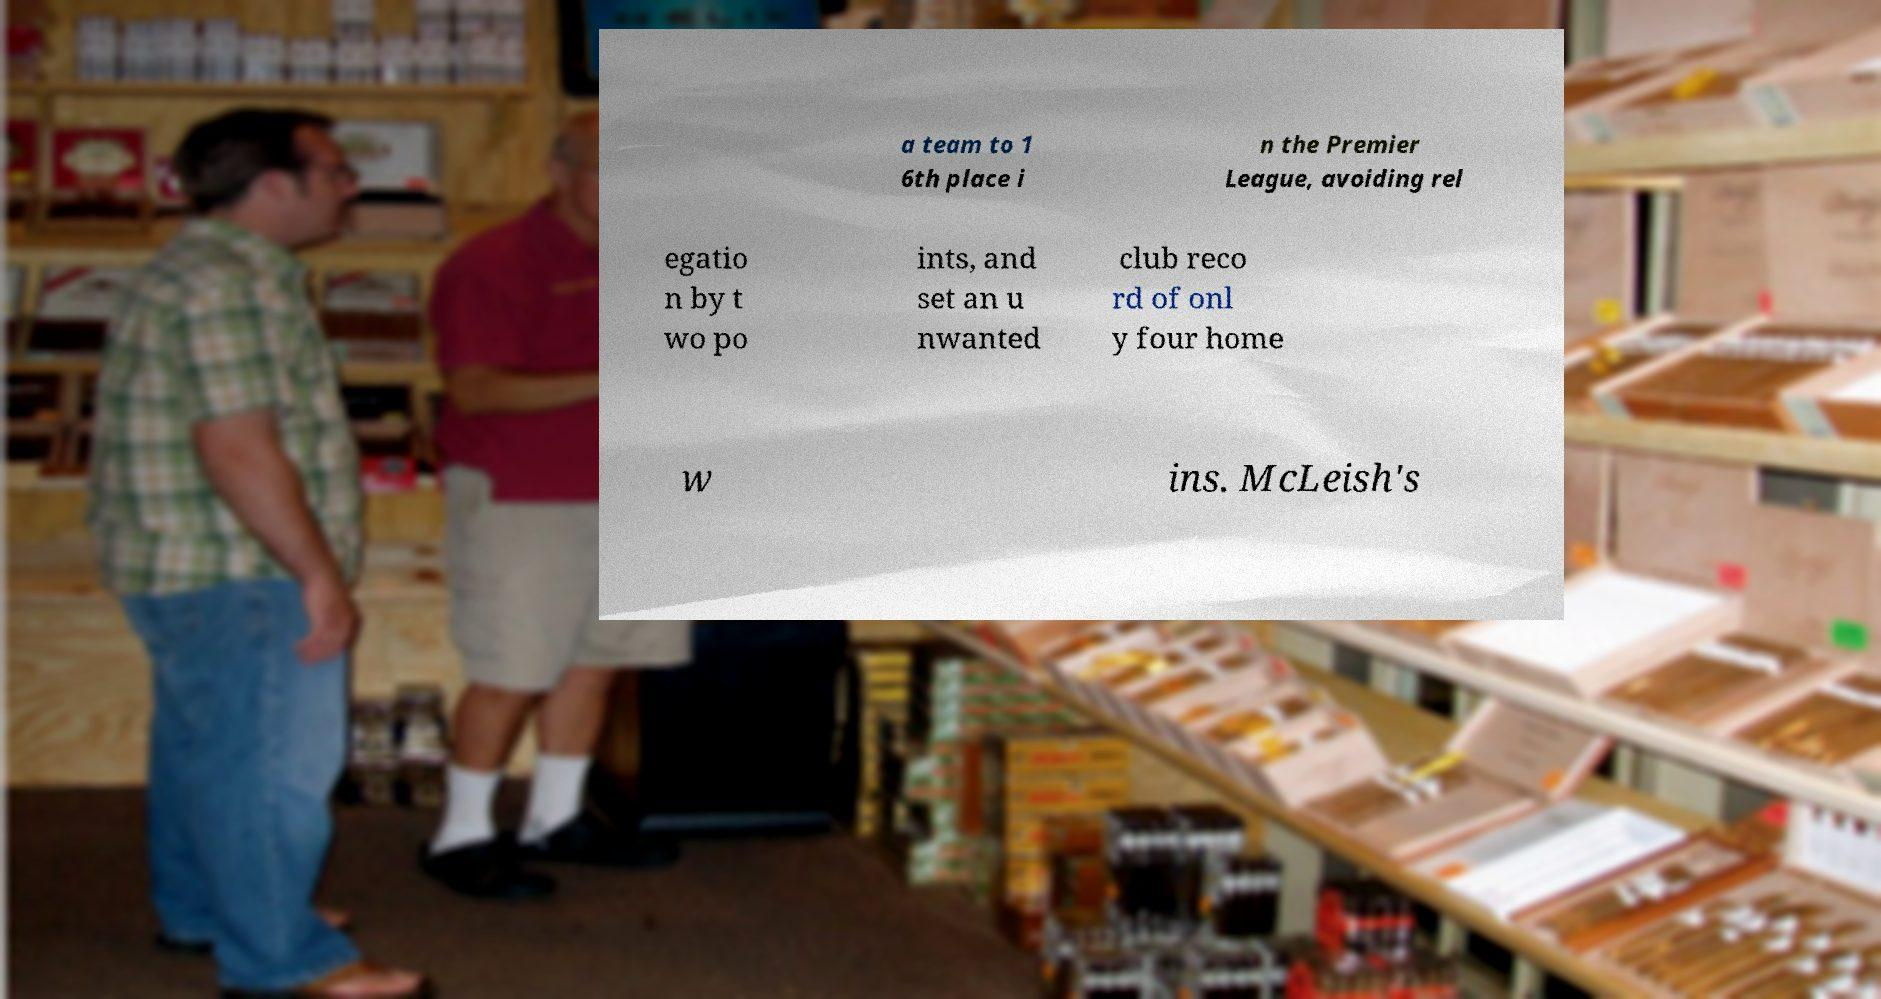For documentation purposes, I need the text within this image transcribed. Could you provide that? a team to 1 6th place i n the Premier League, avoiding rel egatio n by t wo po ints, and set an u nwanted club reco rd of onl y four home w ins. McLeish's 